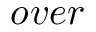<formula> <loc_0><loc_0><loc_500><loc_500>o v e r</formula> 